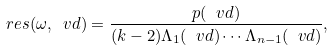Convert formula to latex. <formula><loc_0><loc_0><loc_500><loc_500>\ r e s ( \omega , \ v d ) = \frac { p ( \ v d ) } { ( k - 2 ) \Lambda _ { 1 } ( \ v d ) \cdots \Lambda _ { n - 1 } ( \ v d ) } ,</formula> 